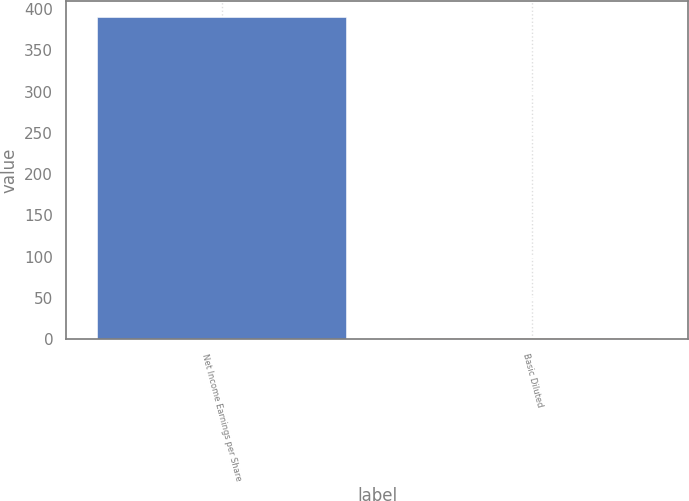<chart> <loc_0><loc_0><loc_500><loc_500><bar_chart><fcel>Net Income Earnings per Share<fcel>Basic Diluted<nl><fcel>390<fcel>1.8<nl></chart> 